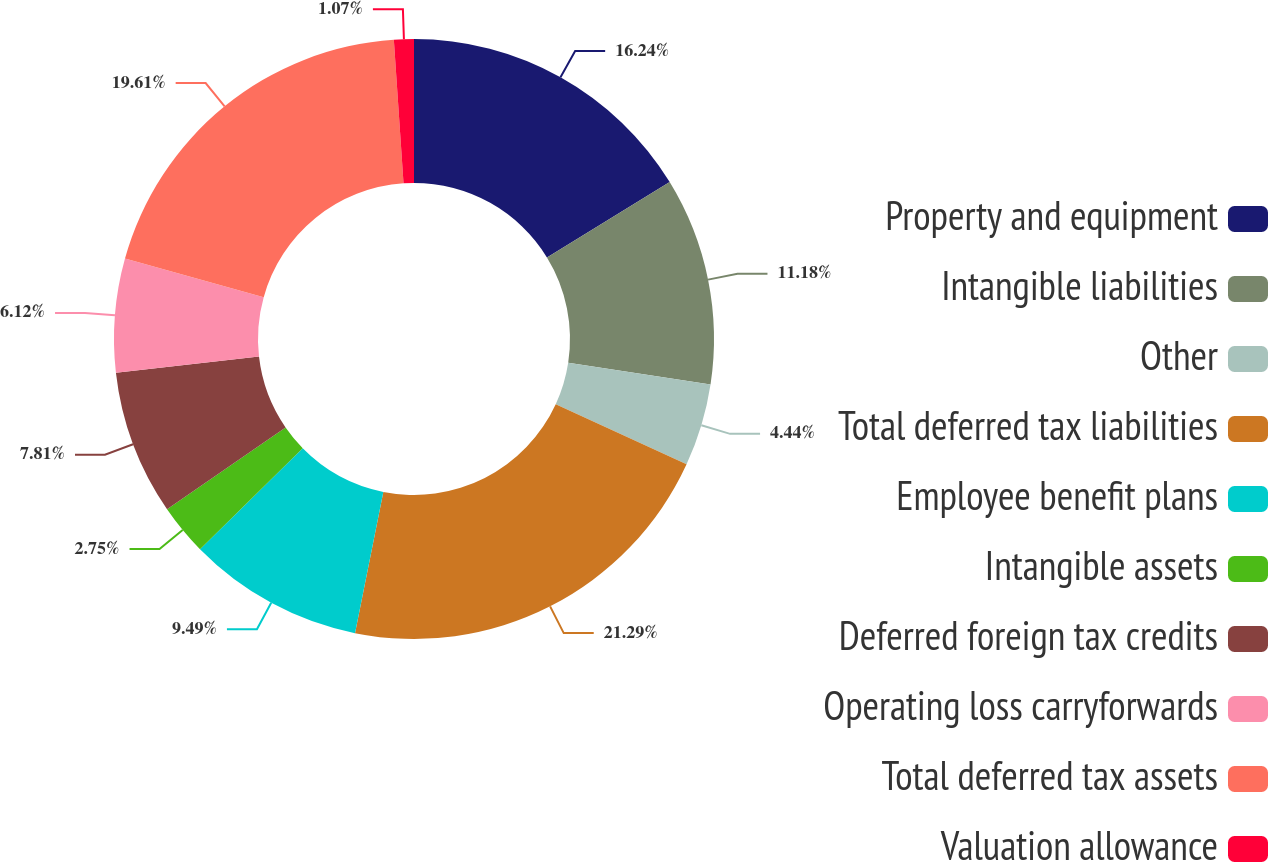Convert chart to OTSL. <chart><loc_0><loc_0><loc_500><loc_500><pie_chart><fcel>Property and equipment<fcel>Intangible liabilities<fcel>Other<fcel>Total deferred tax liabilities<fcel>Employee benefit plans<fcel>Intangible assets<fcel>Deferred foreign tax credits<fcel>Operating loss carryforwards<fcel>Total deferred tax assets<fcel>Valuation allowance<nl><fcel>16.24%<fcel>11.18%<fcel>4.44%<fcel>21.29%<fcel>9.49%<fcel>2.75%<fcel>7.81%<fcel>6.12%<fcel>19.61%<fcel>1.07%<nl></chart> 